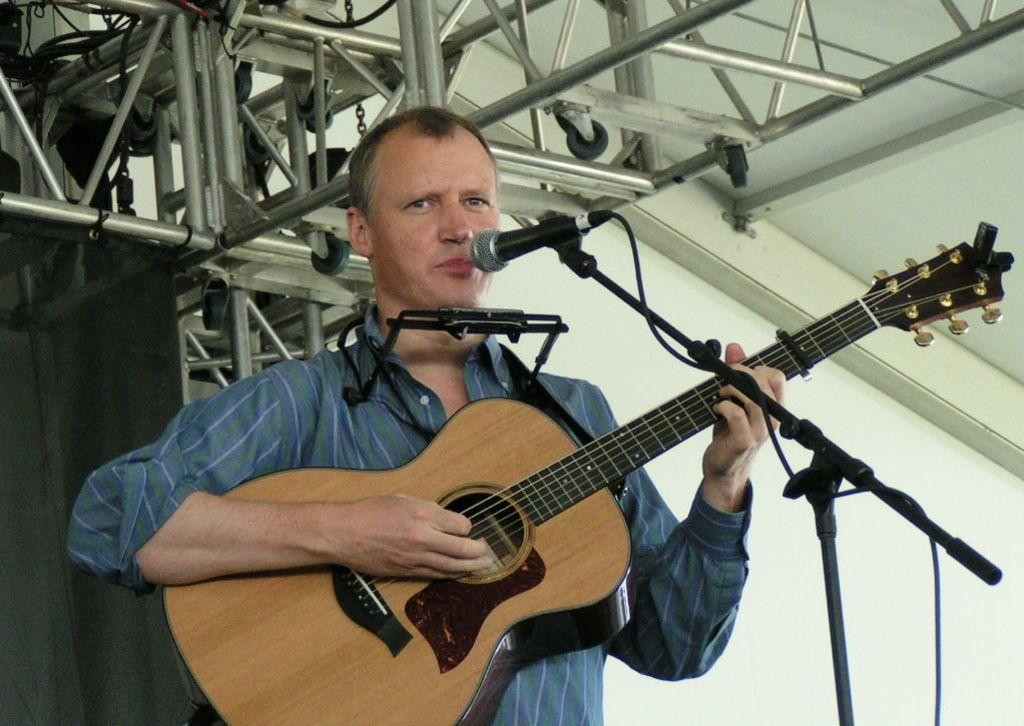Describe this image in one or two sentences. In this image, In the middle there is a man he is standing and he is holding a music instrument which is in yellow color, There is a microphone which is in black color he is singing in the microphone, In the background there is a white color wall and there are white color rods. 